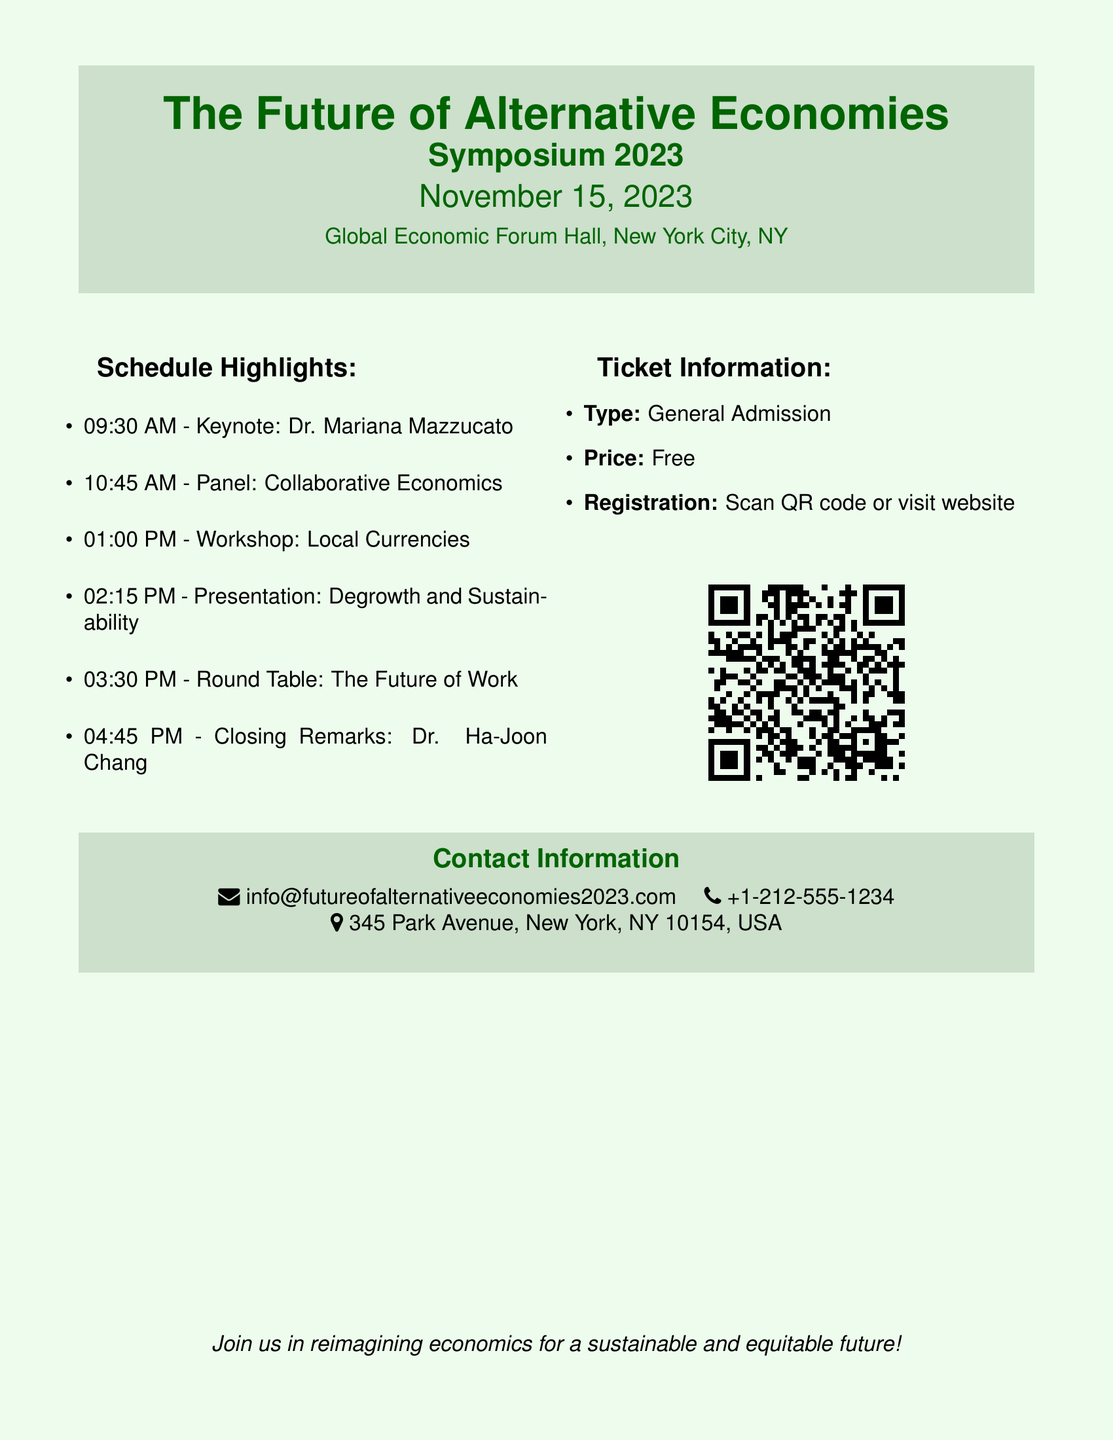What is the date of the symposium? The date is explicitly mentioned in the document under the title section.
Answer: November 15, 2023 Who is the keynote speaker? The keynote speaker is listed in the schedule highlights of the document.
Answer: Dr. Mariana Mazzucato What time does the workshop on local currencies start? The time for the workshop is provided in the schedule highlights section.
Answer: 01:00 PM What type of ticket is available? The ticket type is specified in the ticket information section of the document.
Answer: General Admission What is the registration fee for attendees? The price is mentioned clearly in the ticket information section.
Answer: Free Who provides the closing remarks? The closing remarks speaker is listed in the schedule highlights.
Answer: Dr. Ha-Joon Chang Where is the event taking place? The location is provided in the title section of the document.
Answer: Global Economic Forum Hall, New York City, NY What is the contact email provided? The contact email is detailed in the contact information section.
Answer: info@futureofalternativeeconomies2023.com What is the website link for registration? The registration link is encoded in the QR code and indicated in the ticket information.
Answer: http://www.futureofalternativeeconomies2023.com/register 